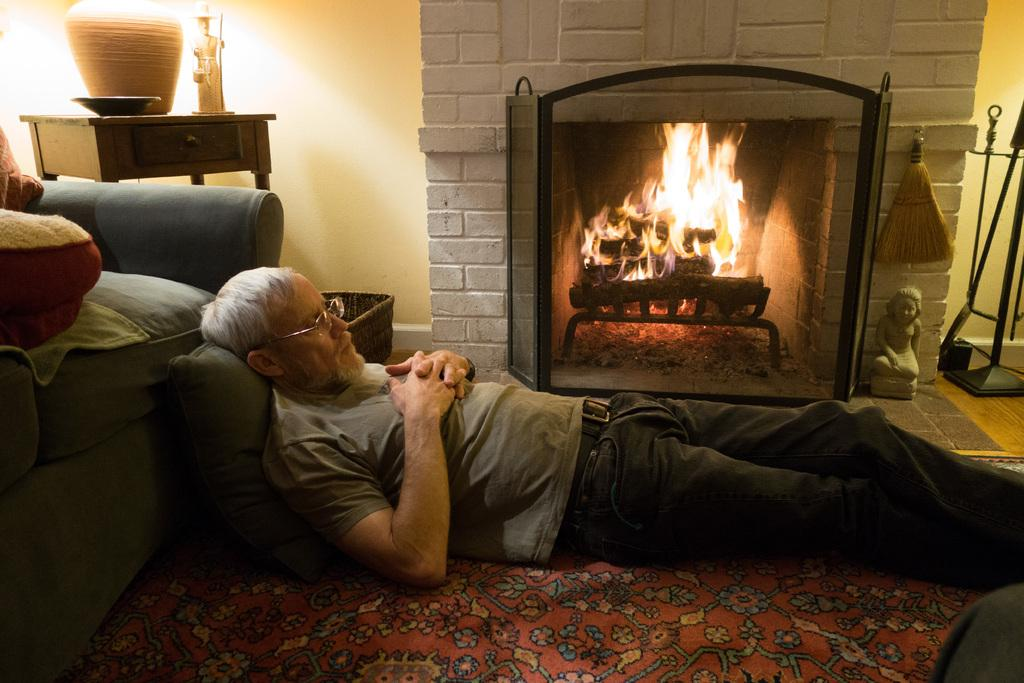What is the person in the image doing? The person is laying on the carpet in the image. What object can be seen near the person? There is a pillow in the image. What type of furniture is present in the image? There is a chair and a table in the image. What can be found on the table? There is a plate on the table in the image. What is the purpose of the pot in the image? The pot might be used for holding plants or other items. What other items can be seen in the image? There are toys and some other items in the image. What is the setting of the image? The image features a fireplace, which suggests a cozy indoor environment. How many giants are playing with the toys in the image? There are no giants present in the image; it features a person laying on the carpet and various objects and furniture. What type of rabbits can be seen interacting with the toys in the image? There are no rabbits present in the image; it features a person laying on the carpet and various objects and furniture. 